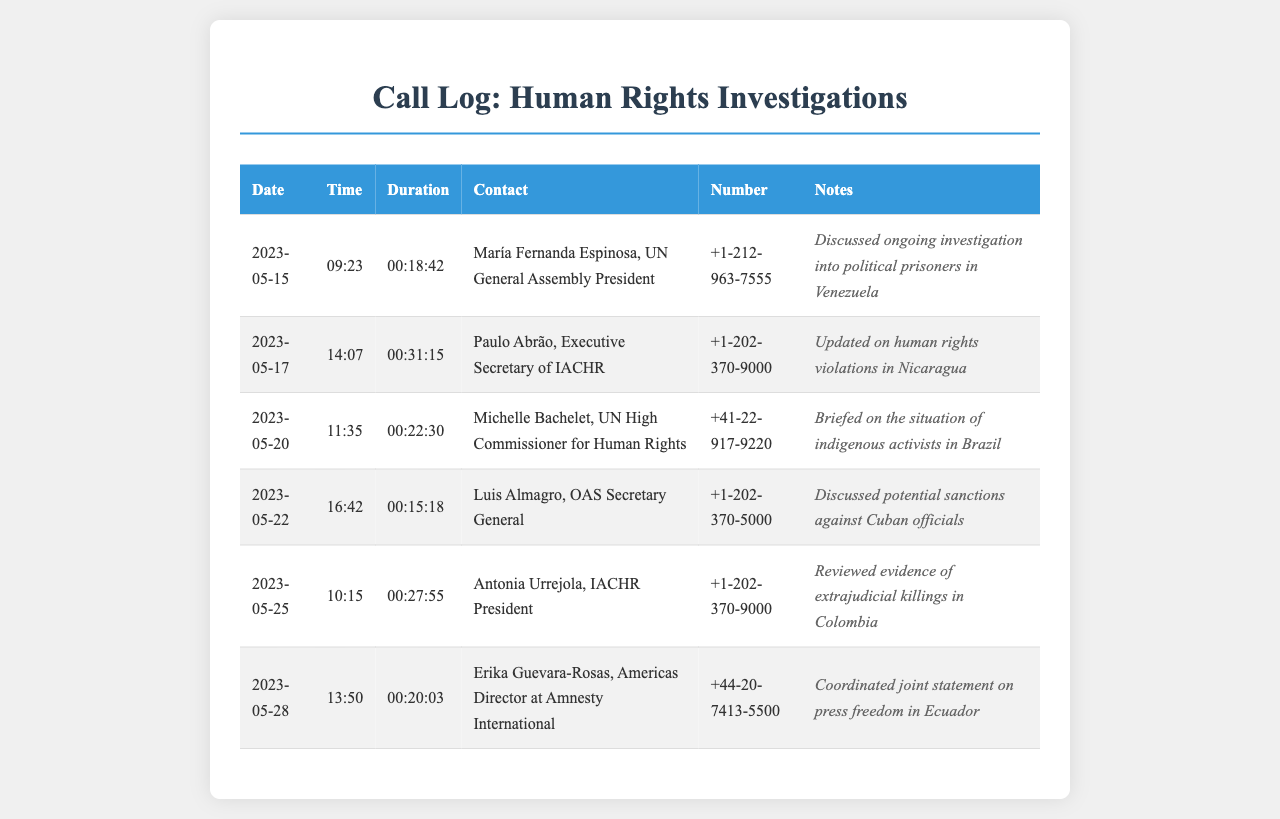What is the date of the call with María Fernanda Espinosa? The date is listed in the first row of the call log where María Fernanda Espinosa is mentioned.
Answer: 2023-05-15 Who was the contact on May 17? The contact's name for that date is found in the second row of the call log.
Answer: Paulo Abrão What was the duration of the call on May 20? The duration is specified in the third row of the call log alongside the contact name.
Answer: 00:22:30 Which government official was discussed on May 22? The official discussed is identified in the notes section of the entry for that date.
Answer: Cuban officials How many calls were made to IACHR officials? IACHR officials are mentioned in two entries of the call log.
Answer: 2 What was the purpose of the call to Antonia Urrejola? The purpose is described in the notes of the corresponding entry in the call log.
Answer: Reviewed evidence of extrajudicial killings in Colombia What is the total number of calls listed in the log? The total number of calls is determined by counting all entries in the document table.
Answer: 6 Who coordinates the joint statement on press freedom? The person coordinating is specified in the notes for the call dated May 28.
Answer: Erika Guevara-Rosas What organization does Luis Almagro represent? The organization is mentioned in the contact's title in the call log.
Answer: OAS 